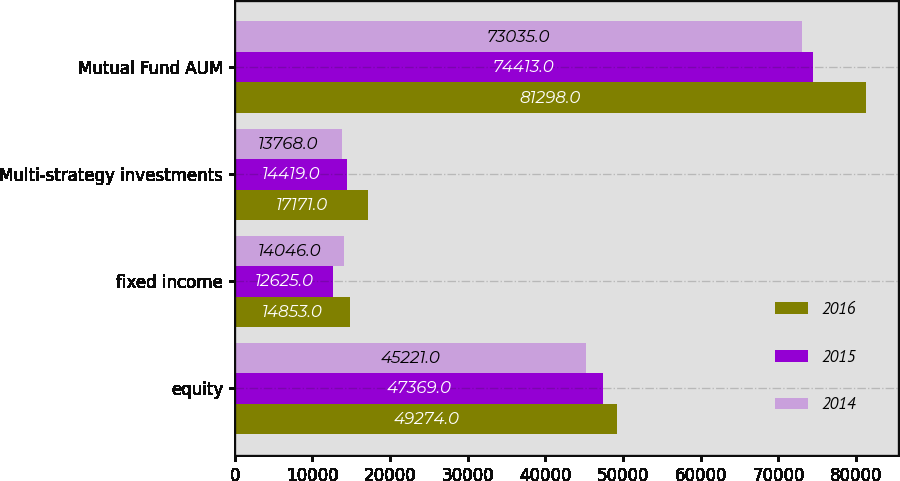<chart> <loc_0><loc_0><loc_500><loc_500><stacked_bar_chart><ecel><fcel>equity<fcel>fixed income<fcel>Multi-strategy investments<fcel>Mutual Fund AUM<nl><fcel>2016<fcel>49274<fcel>14853<fcel>17171<fcel>81298<nl><fcel>2015<fcel>47369<fcel>12625<fcel>14419<fcel>74413<nl><fcel>2014<fcel>45221<fcel>14046<fcel>13768<fcel>73035<nl></chart> 